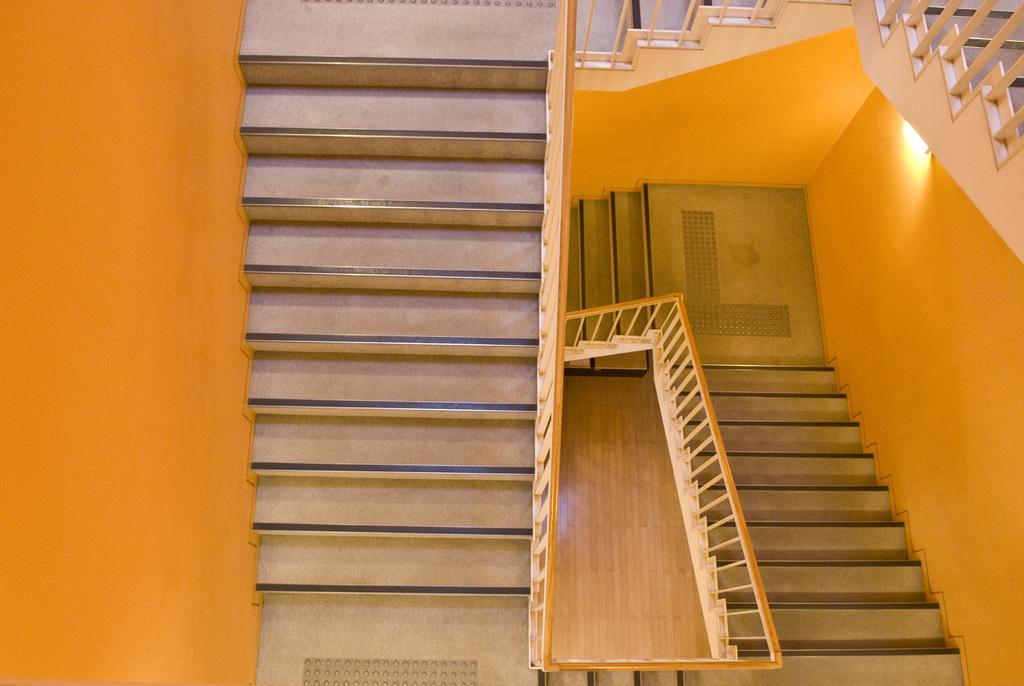Describe this image in one or two sentences. In this picture we can see stairs and a light. 